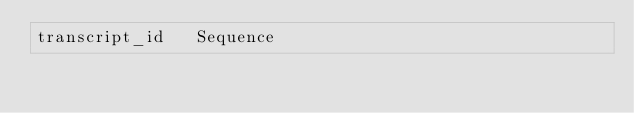Convert code to text. <code><loc_0><loc_0><loc_500><loc_500><_SQL_>transcript_id	Sequence</code> 